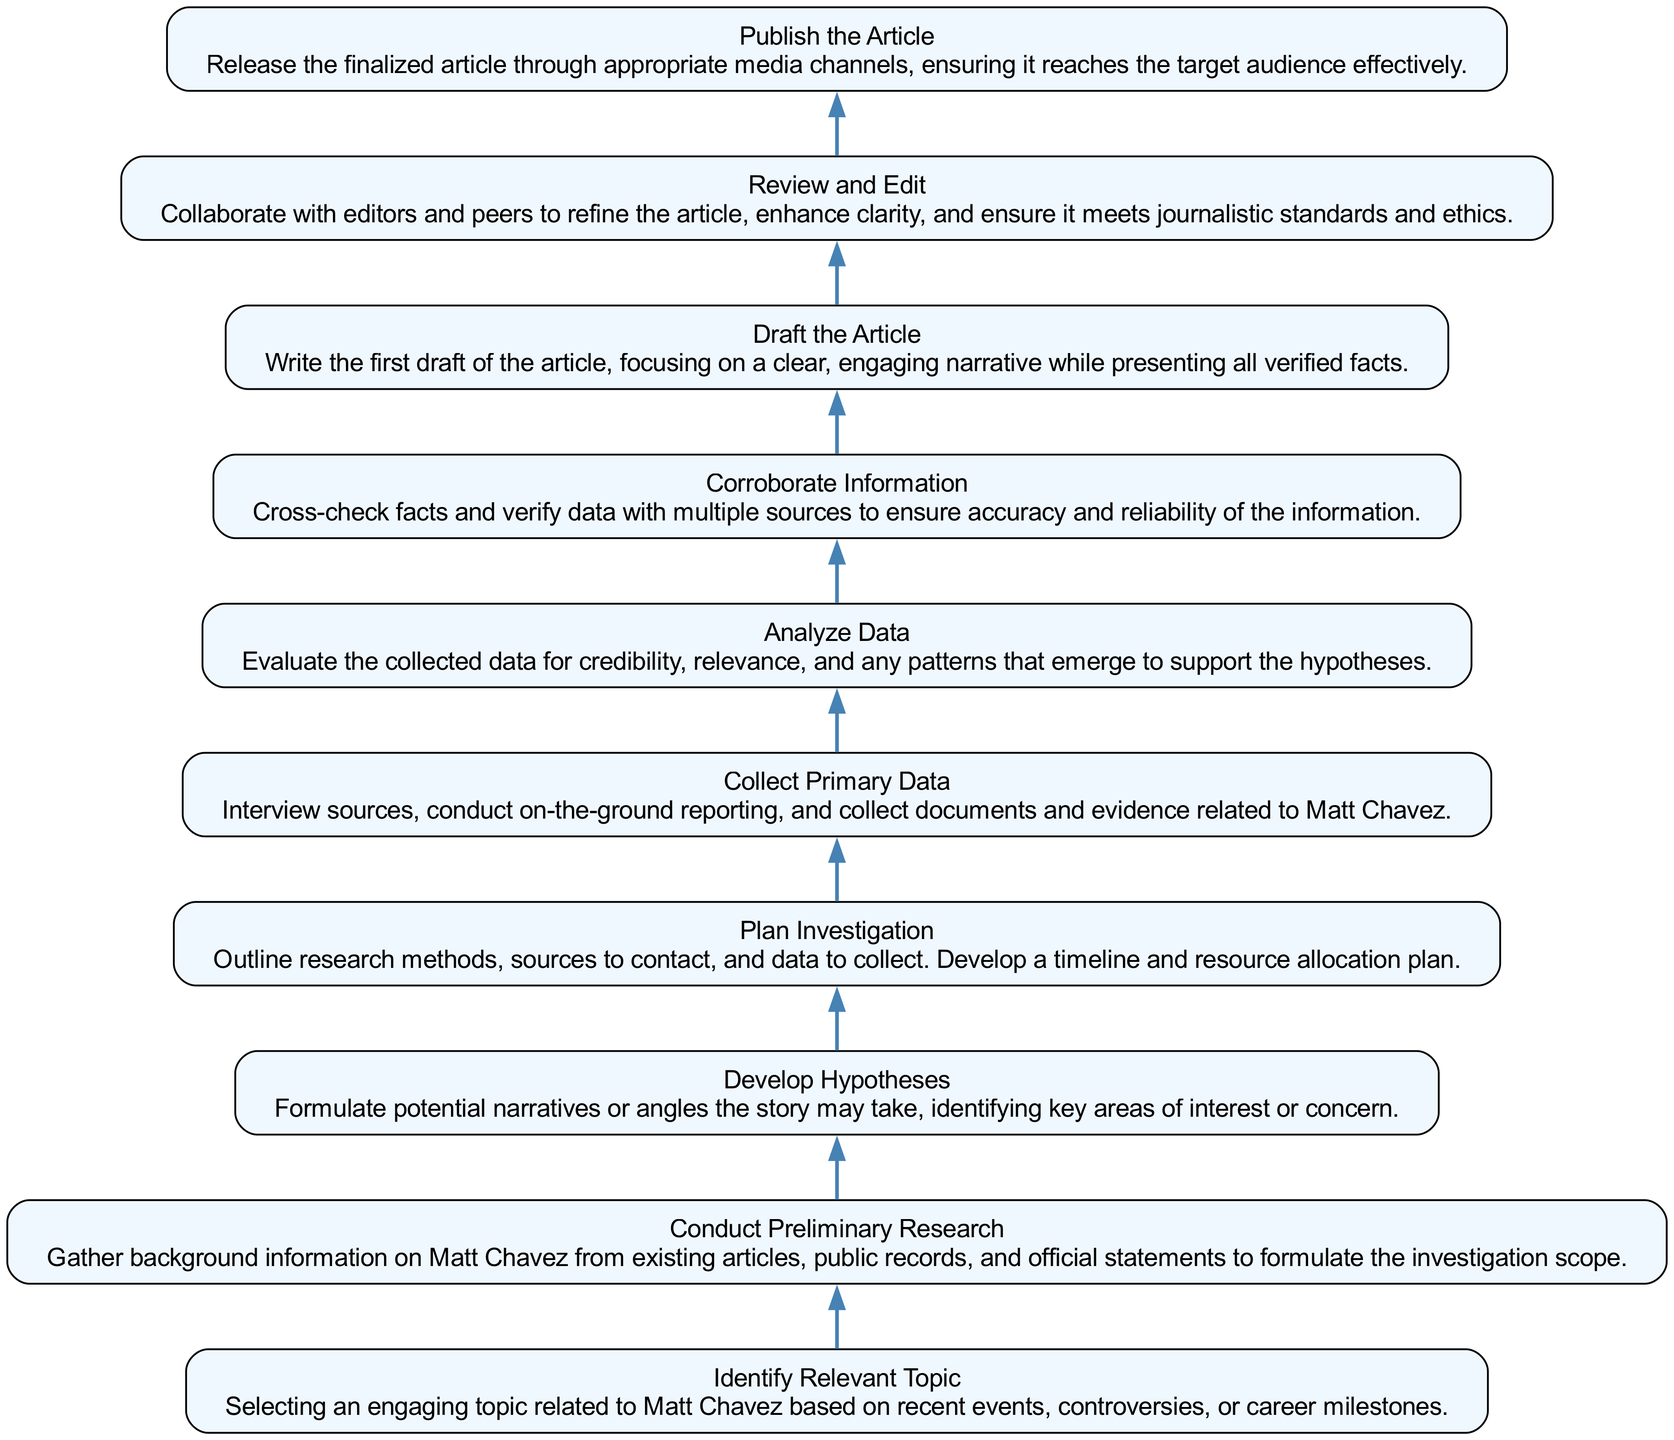What is the first step in the investigative journalism process? The diagram indicates that the first step is "Identify Relevant Topic", as it is the bottom-most node in the flowchart and starts the investigative process.
Answer: Identify Relevant Topic How many total steps are present in this diagram? By counting each node in the diagram, we find there are 10 distinct steps outlining the investigative journalism process regarding Matt Chavez.
Answer: 10 What is the last step in the process? The top-most node of the diagram shows that the last step is "Publish the Article", concluding the flow of the investigative journalism process.
Answer: Publish the Article What follows "Analyze Data"? According to the diagram, "Corroborate Information" follows "Analyze Data", indicating it is the next step in the process of verification and accuracy.
Answer: Corroborate Information What is the relationship between "Conduct Preliminary Research" and "Develop Hypotheses"? The flow of the diagram illustrates that "Develop Hypotheses" comes directly after "Conduct Preliminary Research", indicating a sequential relationship in the investigative steps.
Answer: Develop Hypotheses Which step involves checking facts for accuracy? The label "Corroborate Information" explicitly states that this step is dedicated to cross-checking facts and verifying data with multiple sources for accuracy.
Answer: Corroborate Information What does the "Draft the Article" step focus on? The description with "Draft the Article" states it focuses on creating the first draft with a clear narrative while ensuring all verified facts are included, emphasizing narrative and accuracy.
Answer: Clear, engaging narrative What step comes before "Plan Investigation"? In reviewing the diagram, "Develop Hypotheses" is the step that immediately precedes "Plan Investigation", as indicated by the flow direction.
Answer: Develop Hypotheses Which two steps are focused on data collection and verification? The steps "Collect Primary Data" and "Corroborate Information" specifically address the gathering and verification of data in the investigative journalism process.
Answer: Collect Primary Data and Corroborate Information 